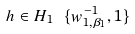Convert formula to latex. <formula><loc_0><loc_0><loc_500><loc_500>h \in H _ { 1 } \ \{ w _ { 1 , \beta _ { 1 } } ^ { - 1 } , 1 \}</formula> 